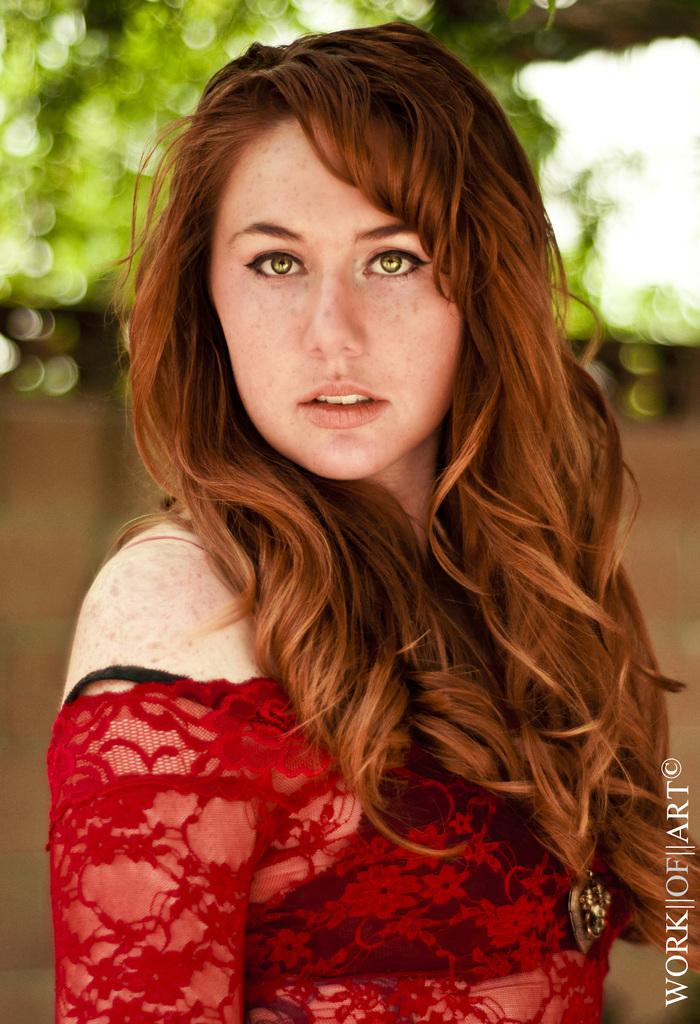Who is the main subject in the image? There is a woman in the image. What is the woman wearing? The woman is wearing a red dress. What can be seen on the right side of the image? There is a watermark on the right side of the image. What is visible in the background of the image? There is a wall and trees in the background of the image. What type of digestion is the woman experiencing in the image? There is no indication of digestion in the image, as it focuses on the woman's appearance and the background. What tools might the carpenter be using in the image? There is no carpenter or tools present in the image; it features a woman in a red dress with a background of a wall and trees. 